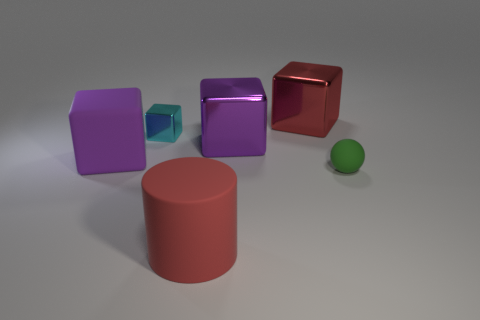Subtract all blue cubes. Subtract all yellow balls. How many cubes are left? 4 Add 2 tiny shiny objects. How many objects exist? 8 Subtract all blocks. How many objects are left? 2 Add 6 cyan things. How many cyan things are left? 7 Add 5 red things. How many red things exist? 7 Subtract 1 red cylinders. How many objects are left? 5 Subtract all large yellow matte cylinders. Subtract all big purple matte blocks. How many objects are left? 5 